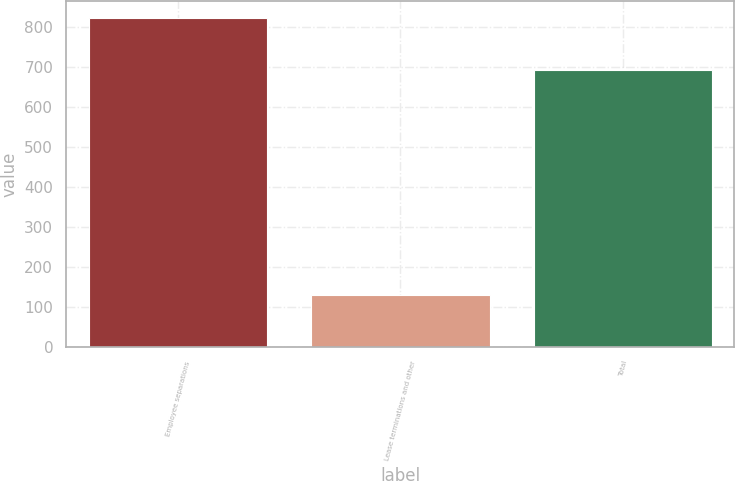<chart> <loc_0><loc_0><loc_500><loc_500><bar_chart><fcel>Employee separations<fcel>Lease terminations and other<fcel>Total<nl><fcel>823<fcel>131<fcel>692<nl></chart> 